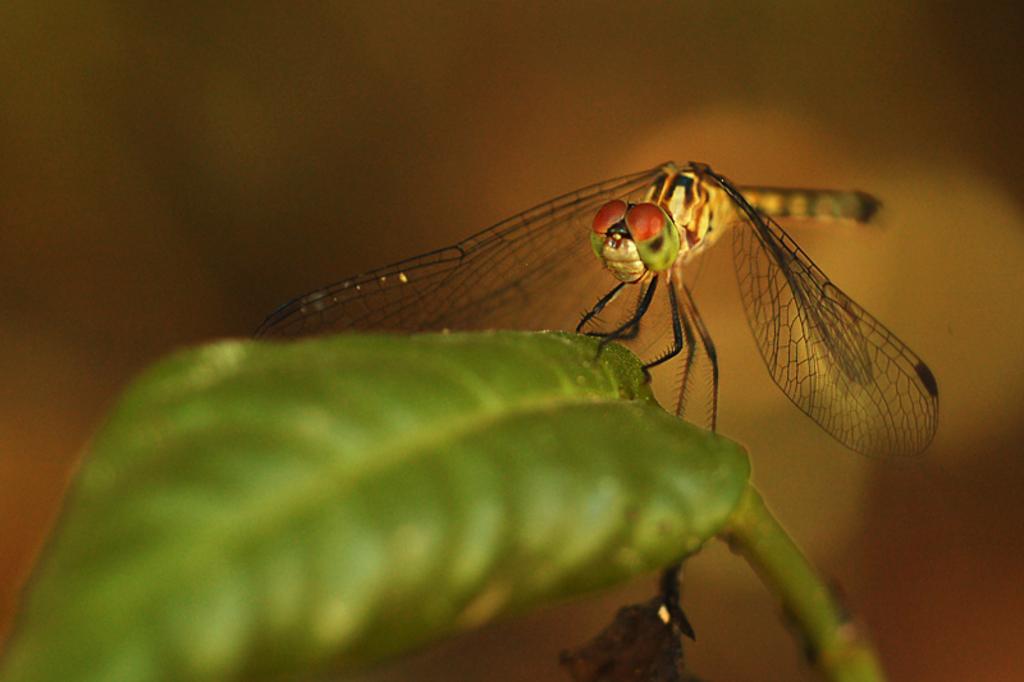Can you describe this image briefly? We can see dragonfly on green leaf. In the background it is blur. 